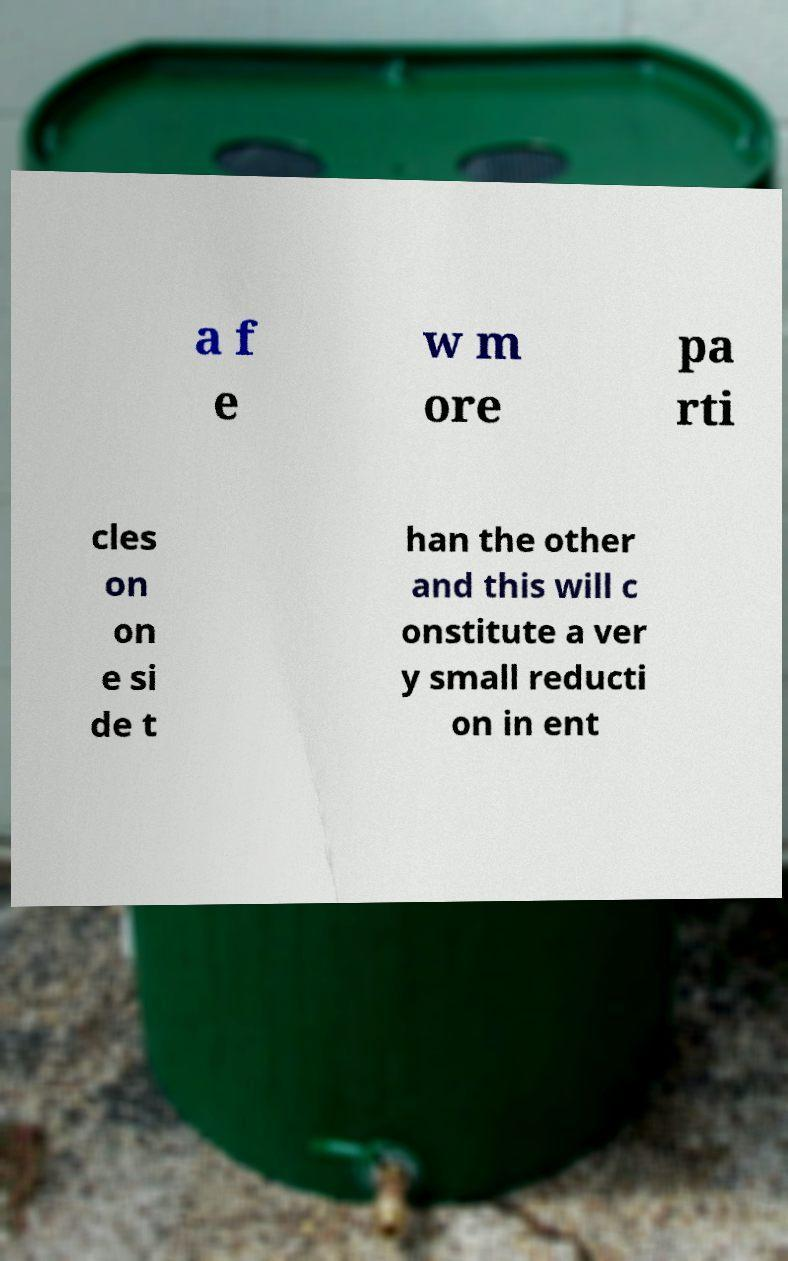There's text embedded in this image that I need extracted. Can you transcribe it verbatim? a f e w m ore pa rti cles on on e si de t han the other and this will c onstitute a ver y small reducti on in ent 